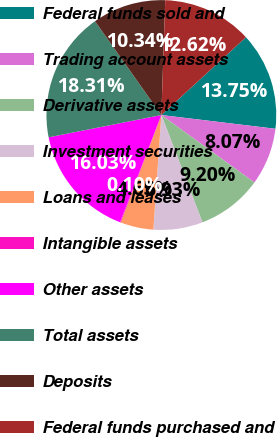<chart> <loc_0><loc_0><loc_500><loc_500><pie_chart><fcel>Federal funds sold and<fcel>Trading account assets<fcel>Derivative assets<fcel>Investment securities<fcel>Loans and leases<fcel>Intangible assets<fcel>Other assets<fcel>Total assets<fcel>Deposits<fcel>Federal funds purchased and<nl><fcel>13.75%<fcel>8.07%<fcel>9.2%<fcel>6.93%<fcel>4.65%<fcel>0.1%<fcel>16.03%<fcel>18.31%<fcel>10.34%<fcel>12.62%<nl></chart> 